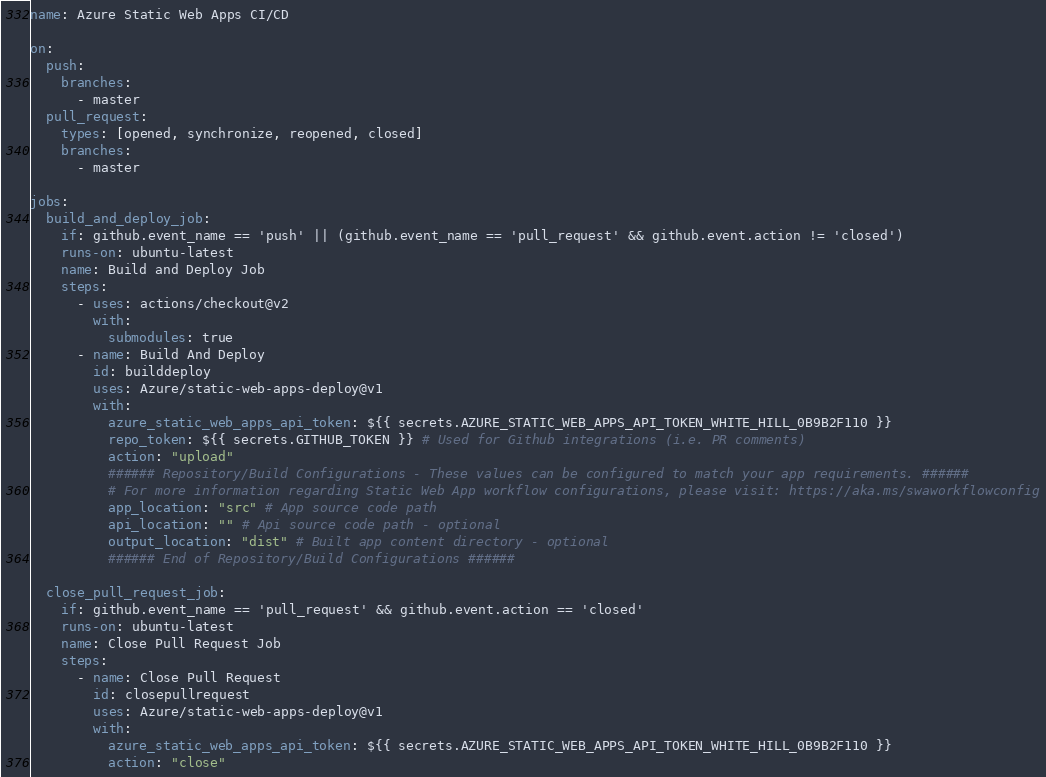Convert code to text. <code><loc_0><loc_0><loc_500><loc_500><_YAML_>name: Azure Static Web Apps CI/CD

on:
  push:
    branches:
      - master
  pull_request:
    types: [opened, synchronize, reopened, closed]
    branches:
      - master

jobs:
  build_and_deploy_job:
    if: github.event_name == 'push' || (github.event_name == 'pull_request' && github.event.action != 'closed')
    runs-on: ubuntu-latest
    name: Build and Deploy Job
    steps:
      - uses: actions/checkout@v2
        with:
          submodules: true
      - name: Build And Deploy
        id: builddeploy
        uses: Azure/static-web-apps-deploy@v1
        with:
          azure_static_web_apps_api_token: ${{ secrets.AZURE_STATIC_WEB_APPS_API_TOKEN_WHITE_HILL_0B9B2F110 }}
          repo_token: ${{ secrets.GITHUB_TOKEN }} # Used for Github integrations (i.e. PR comments)
          action: "upload"
          ###### Repository/Build Configurations - These values can be configured to match your app requirements. ######
          # For more information regarding Static Web App workflow configurations, please visit: https://aka.ms/swaworkflowconfig
          app_location: "src" # App source code path
          api_location: "" # Api source code path - optional
          output_location: "dist" # Built app content directory - optional
          ###### End of Repository/Build Configurations ######

  close_pull_request_job:
    if: github.event_name == 'pull_request' && github.event.action == 'closed'
    runs-on: ubuntu-latest
    name: Close Pull Request Job
    steps:
      - name: Close Pull Request
        id: closepullrequest
        uses: Azure/static-web-apps-deploy@v1
        with:
          azure_static_web_apps_api_token: ${{ secrets.AZURE_STATIC_WEB_APPS_API_TOKEN_WHITE_HILL_0B9B2F110 }}
          action: "close"
</code> 